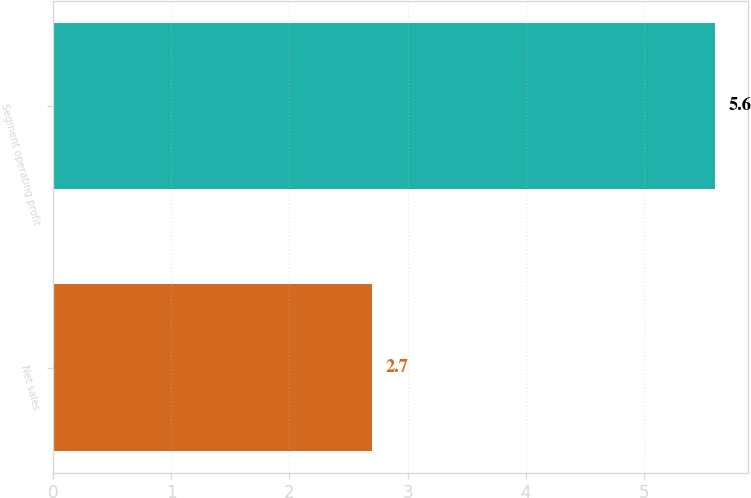Convert chart to OTSL. <chart><loc_0><loc_0><loc_500><loc_500><bar_chart><fcel>Net sales<fcel>Segment operating profit<nl><fcel>2.7<fcel>5.6<nl></chart> 